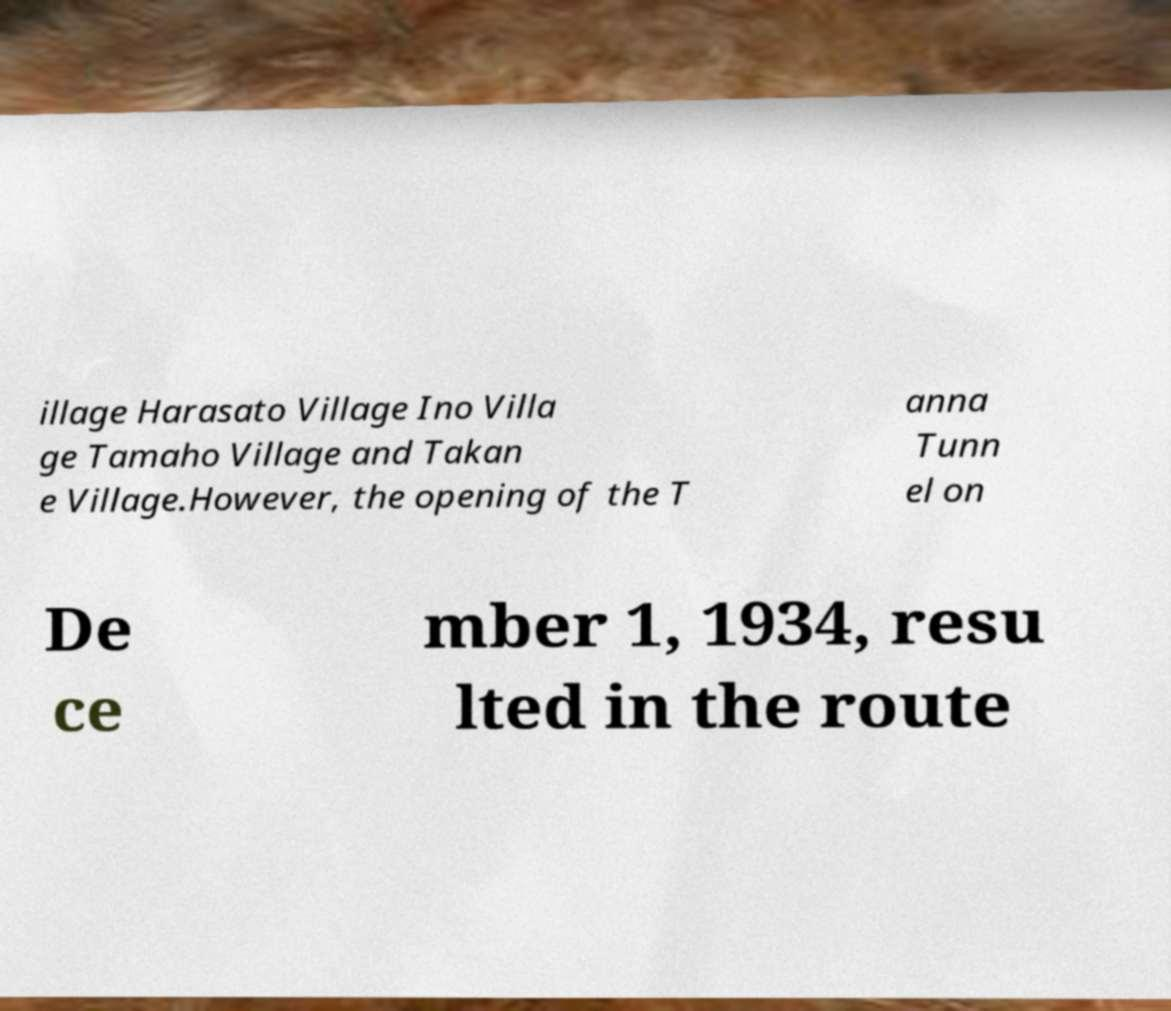What messages or text are displayed in this image? I need them in a readable, typed format. illage Harasato Village Ino Villa ge Tamaho Village and Takan e Village.However, the opening of the T anna Tunn el on De ce mber 1, 1934, resu lted in the route 